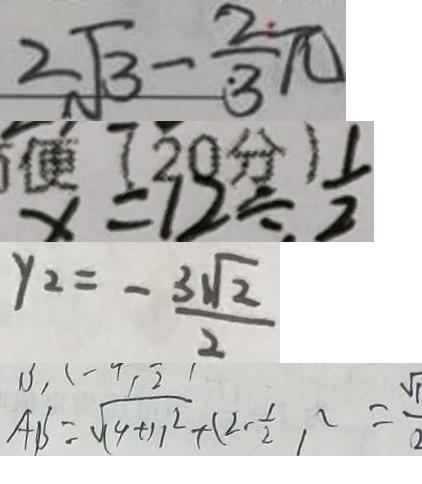Convert formula to latex. <formula><loc_0><loc_0><loc_500><loc_500>2 \sqrt { 3 } - \frac { 2 } { 3 } \pi 
 x = 1 2 \div \frac { 1 } { 2 } 
 y 2 = - \frac { 3 \sqrt { 2 } } { 2 } 
 A B = \sqrt { ( 4 + 1 ) ^ { 2 } } + ( 2 - \frac { 1 } { 2 } ) ^ { 2 } = \frac { \sqrt { 1 } } { 2 }</formula> 